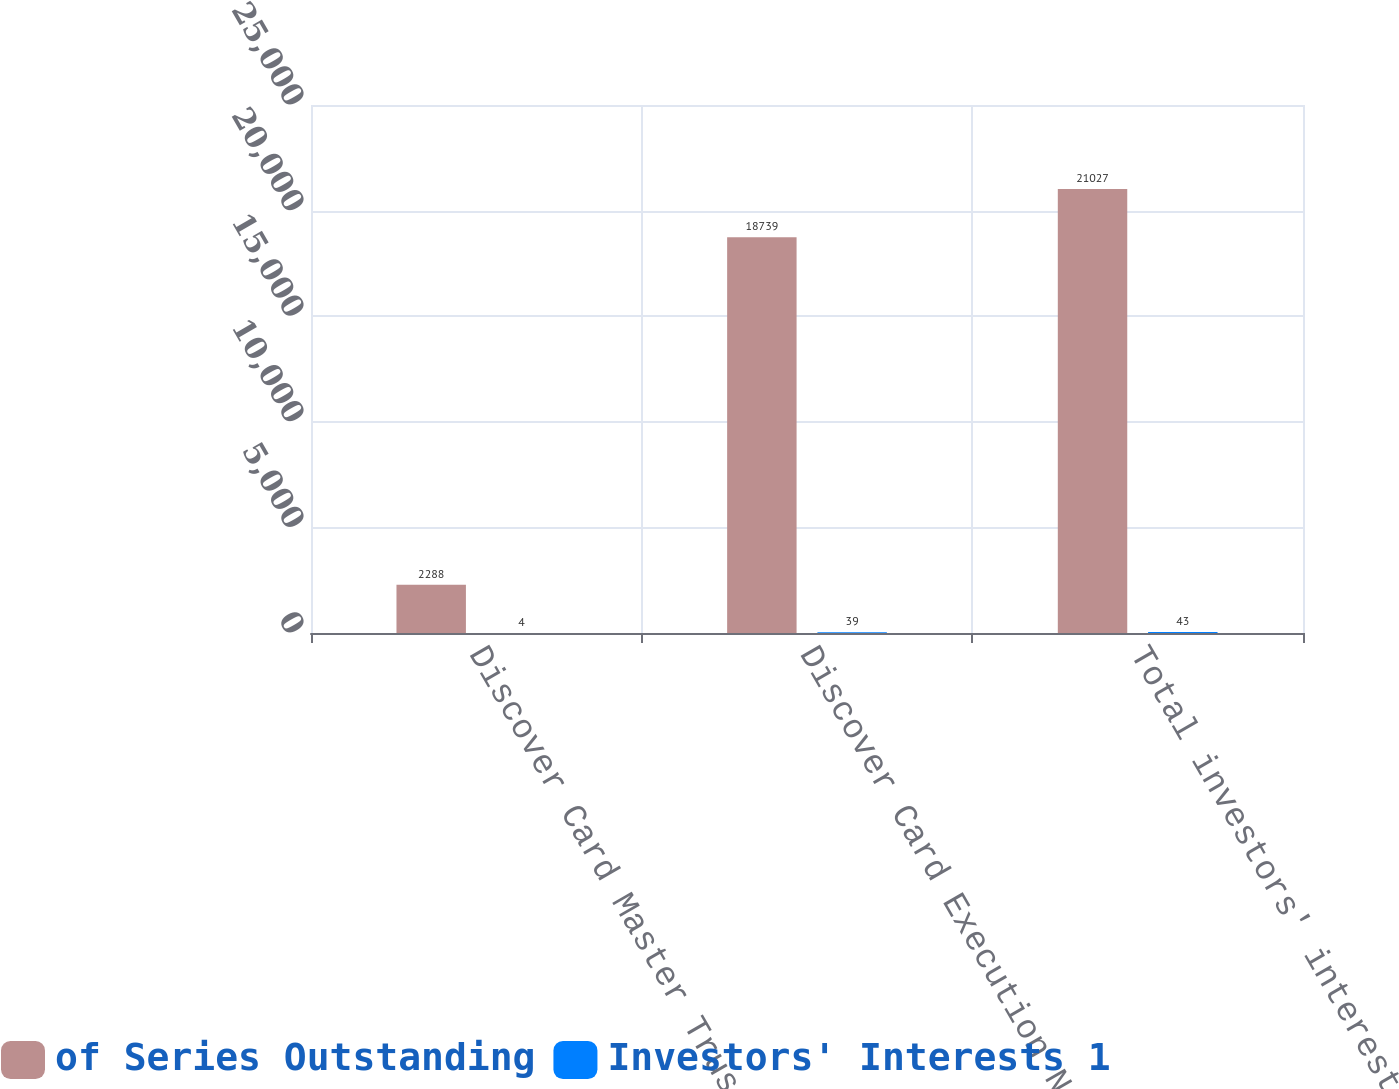<chart> <loc_0><loc_0><loc_500><loc_500><stacked_bar_chart><ecel><fcel>Discover Card Master Trust I<fcel>Discover Card Execution Note<fcel>Total investors' interests<nl><fcel>of Series Outstanding<fcel>2288<fcel>18739<fcel>21027<nl><fcel>Investors' Interests 1<fcel>4<fcel>39<fcel>43<nl></chart> 